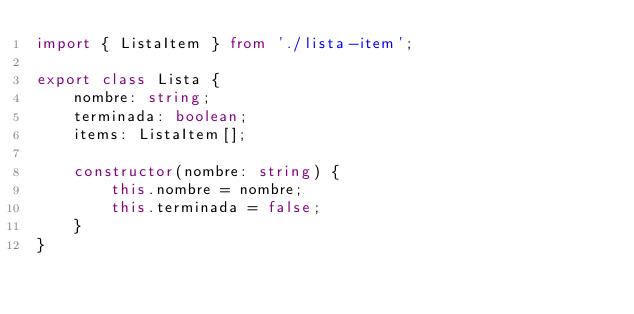Convert code to text. <code><loc_0><loc_0><loc_500><loc_500><_TypeScript_>import { ListaItem } from './lista-item';

export class Lista {
    nombre: string;
    terminada: boolean;
    items: ListaItem[];

    constructor(nombre: string) {
        this.nombre = nombre;
        this.terminada = false;
    }
}</code> 